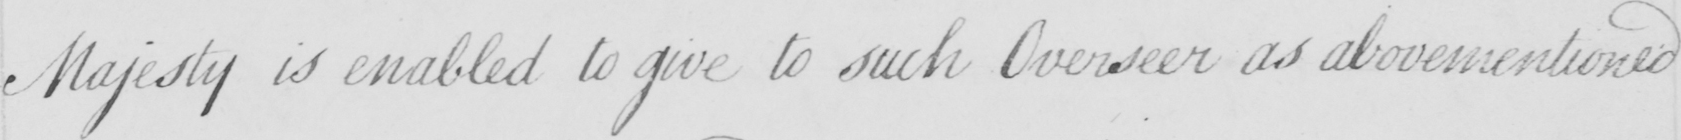Please provide the text content of this handwritten line. Majesty is enabled to give to such Overseer as abovementioned 